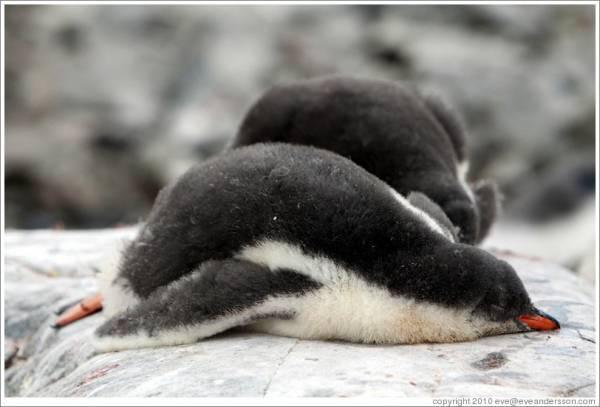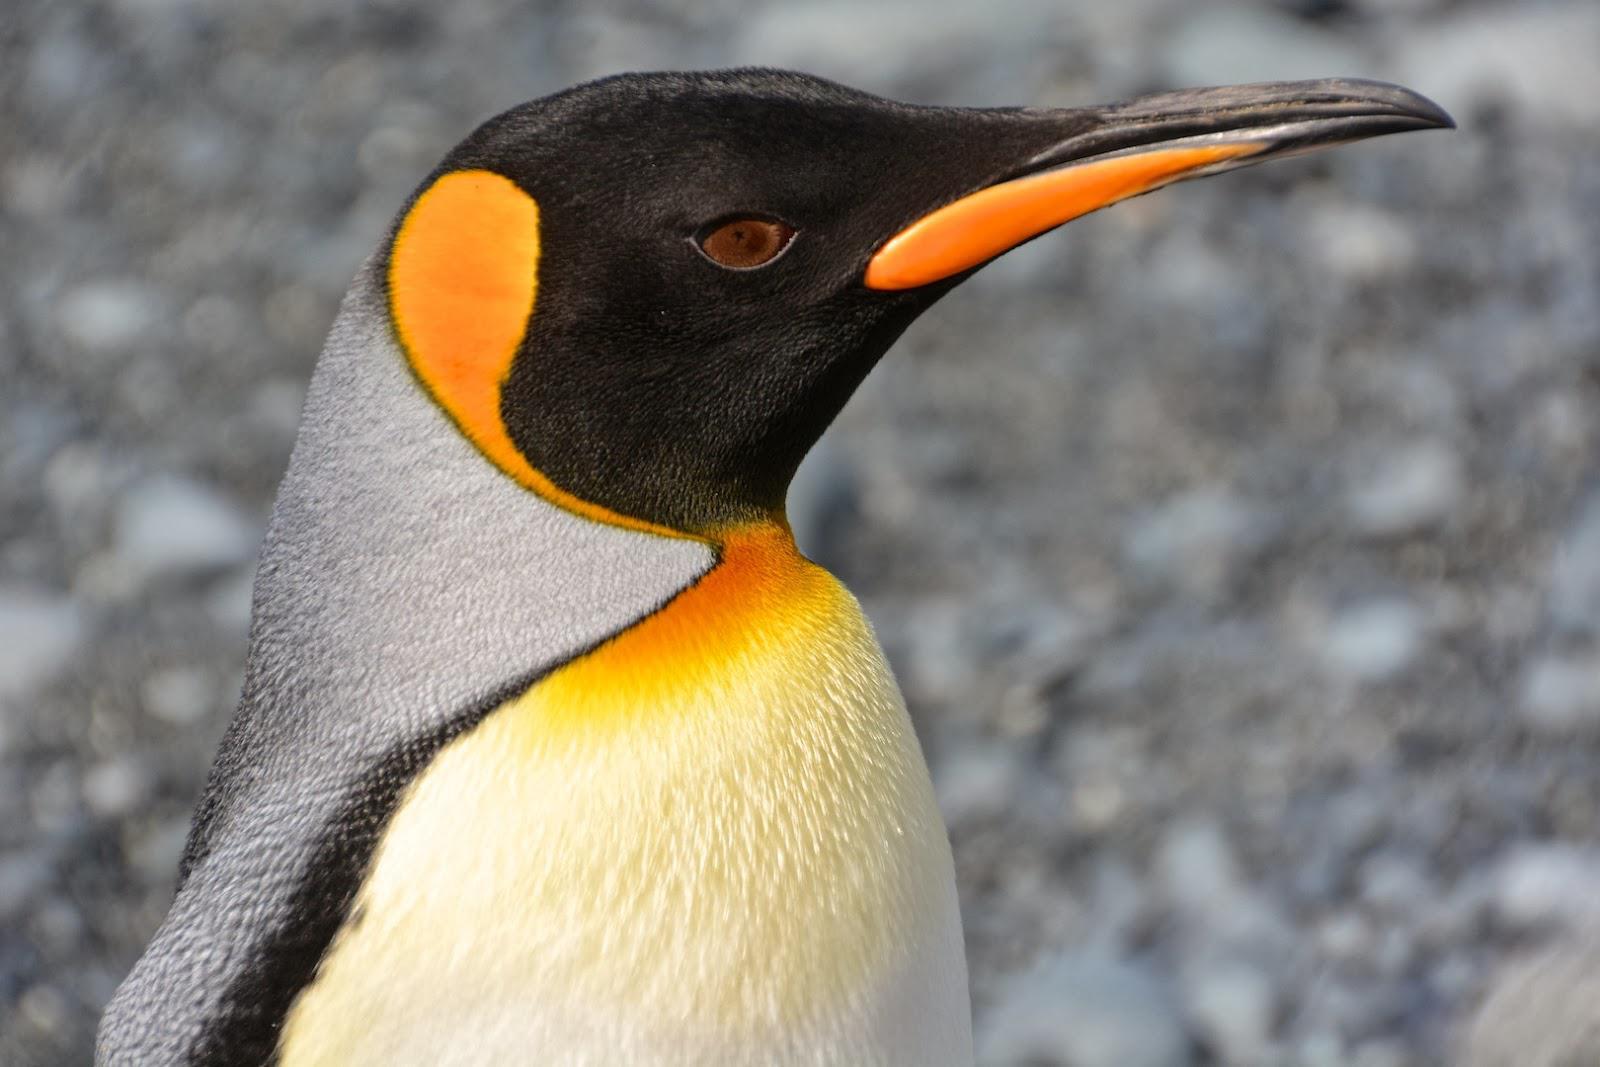The first image is the image on the left, the second image is the image on the right. Assess this claim about the two images: "One image has a penguin surrounded by grass and rocks.". Correct or not? Answer yes or no. No. The first image is the image on the left, the second image is the image on the right. Assess this claim about the two images: "At least one of the images includes a penguin that is lying down.". Correct or not? Answer yes or no. Yes. 